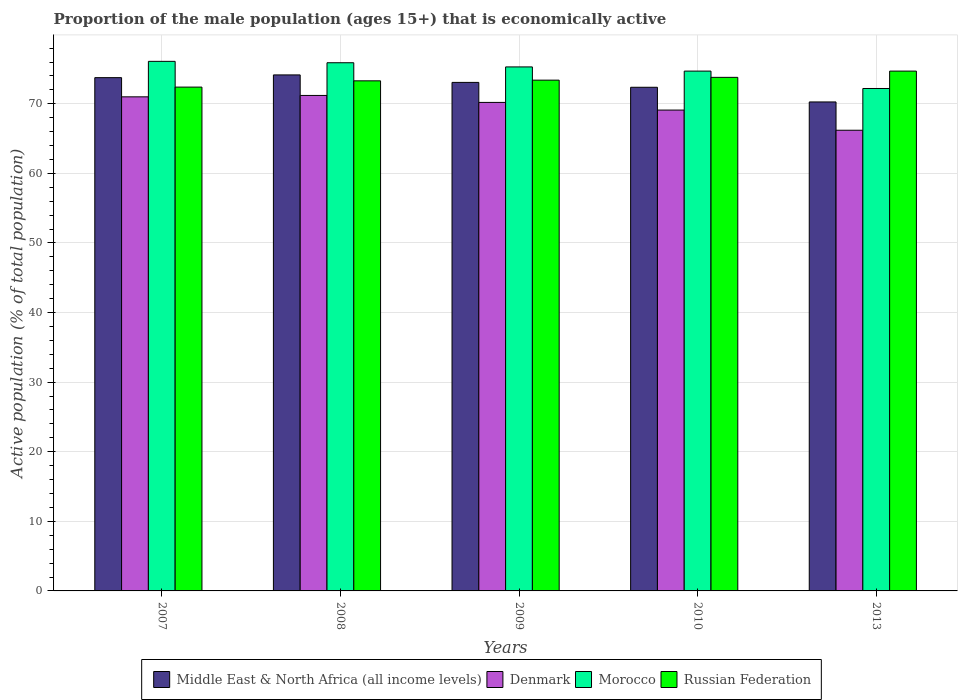How many different coloured bars are there?
Your response must be concise. 4. Are the number of bars per tick equal to the number of legend labels?
Provide a short and direct response. Yes. How many bars are there on the 2nd tick from the right?
Your answer should be very brief. 4. What is the proportion of the male population that is economically active in Denmark in 2010?
Offer a very short reply. 69.1. Across all years, what is the maximum proportion of the male population that is economically active in Morocco?
Your response must be concise. 76.1. Across all years, what is the minimum proportion of the male population that is economically active in Middle East & North Africa (all income levels)?
Your response must be concise. 70.27. What is the total proportion of the male population that is economically active in Russian Federation in the graph?
Your response must be concise. 367.6. What is the difference between the proportion of the male population that is economically active in Denmark in 2007 and that in 2009?
Give a very brief answer. 0.8. What is the difference between the proportion of the male population that is economically active in Denmark in 2009 and the proportion of the male population that is economically active in Morocco in 2013?
Provide a short and direct response. -2. What is the average proportion of the male population that is economically active in Denmark per year?
Give a very brief answer. 69.54. In the year 2007, what is the difference between the proportion of the male population that is economically active in Morocco and proportion of the male population that is economically active in Middle East & North Africa (all income levels)?
Offer a terse response. 2.34. In how many years, is the proportion of the male population that is economically active in Denmark greater than 52 %?
Provide a short and direct response. 5. What is the ratio of the proportion of the male population that is economically active in Morocco in 2008 to that in 2010?
Provide a succinct answer. 1.02. Is the proportion of the male population that is economically active in Morocco in 2007 less than that in 2008?
Keep it short and to the point. No. What is the difference between the highest and the second highest proportion of the male population that is economically active in Middle East & North Africa (all income levels)?
Make the answer very short. 0.39. What is the difference between the highest and the lowest proportion of the male population that is economically active in Russian Federation?
Keep it short and to the point. 2.3. In how many years, is the proportion of the male population that is economically active in Morocco greater than the average proportion of the male population that is economically active in Morocco taken over all years?
Keep it short and to the point. 3. What does the 3rd bar from the left in 2009 represents?
Your answer should be very brief. Morocco. What does the 2nd bar from the right in 2008 represents?
Offer a very short reply. Morocco. How many bars are there?
Your answer should be very brief. 20. Are all the bars in the graph horizontal?
Your response must be concise. No. How many years are there in the graph?
Keep it short and to the point. 5. What is the difference between two consecutive major ticks on the Y-axis?
Your answer should be very brief. 10. Does the graph contain any zero values?
Provide a short and direct response. No. Does the graph contain grids?
Your response must be concise. Yes. Where does the legend appear in the graph?
Ensure brevity in your answer.  Bottom center. How are the legend labels stacked?
Provide a succinct answer. Horizontal. What is the title of the graph?
Give a very brief answer. Proportion of the male population (ages 15+) that is economically active. Does "Heavily indebted poor countries" appear as one of the legend labels in the graph?
Offer a very short reply. No. What is the label or title of the X-axis?
Your answer should be compact. Years. What is the label or title of the Y-axis?
Your answer should be compact. Active population (% of total population). What is the Active population (% of total population) in Middle East & North Africa (all income levels) in 2007?
Your answer should be very brief. 73.76. What is the Active population (% of total population) in Denmark in 2007?
Your answer should be compact. 71. What is the Active population (% of total population) of Morocco in 2007?
Offer a very short reply. 76.1. What is the Active population (% of total population) of Russian Federation in 2007?
Offer a terse response. 72.4. What is the Active population (% of total population) in Middle East & North Africa (all income levels) in 2008?
Keep it short and to the point. 74.15. What is the Active population (% of total population) of Denmark in 2008?
Give a very brief answer. 71.2. What is the Active population (% of total population) of Morocco in 2008?
Offer a terse response. 75.9. What is the Active population (% of total population) of Russian Federation in 2008?
Your answer should be compact. 73.3. What is the Active population (% of total population) in Middle East & North Africa (all income levels) in 2009?
Ensure brevity in your answer.  73.08. What is the Active population (% of total population) in Denmark in 2009?
Provide a short and direct response. 70.2. What is the Active population (% of total population) of Morocco in 2009?
Provide a succinct answer. 75.3. What is the Active population (% of total population) of Russian Federation in 2009?
Give a very brief answer. 73.4. What is the Active population (% of total population) in Middle East & North Africa (all income levels) in 2010?
Provide a short and direct response. 72.38. What is the Active population (% of total population) of Denmark in 2010?
Offer a very short reply. 69.1. What is the Active population (% of total population) in Morocco in 2010?
Provide a succinct answer. 74.7. What is the Active population (% of total population) of Russian Federation in 2010?
Your answer should be very brief. 73.8. What is the Active population (% of total population) of Middle East & North Africa (all income levels) in 2013?
Keep it short and to the point. 70.27. What is the Active population (% of total population) of Denmark in 2013?
Your answer should be very brief. 66.2. What is the Active population (% of total population) of Morocco in 2013?
Ensure brevity in your answer.  72.2. What is the Active population (% of total population) of Russian Federation in 2013?
Your answer should be very brief. 74.7. Across all years, what is the maximum Active population (% of total population) in Middle East & North Africa (all income levels)?
Provide a short and direct response. 74.15. Across all years, what is the maximum Active population (% of total population) of Denmark?
Your answer should be compact. 71.2. Across all years, what is the maximum Active population (% of total population) in Morocco?
Offer a terse response. 76.1. Across all years, what is the maximum Active population (% of total population) of Russian Federation?
Ensure brevity in your answer.  74.7. Across all years, what is the minimum Active population (% of total population) in Middle East & North Africa (all income levels)?
Your answer should be compact. 70.27. Across all years, what is the minimum Active population (% of total population) of Denmark?
Give a very brief answer. 66.2. Across all years, what is the minimum Active population (% of total population) of Morocco?
Provide a short and direct response. 72.2. Across all years, what is the minimum Active population (% of total population) in Russian Federation?
Provide a succinct answer. 72.4. What is the total Active population (% of total population) of Middle East & North Africa (all income levels) in the graph?
Give a very brief answer. 363.63. What is the total Active population (% of total population) of Denmark in the graph?
Make the answer very short. 347.7. What is the total Active population (% of total population) in Morocco in the graph?
Provide a short and direct response. 374.2. What is the total Active population (% of total population) of Russian Federation in the graph?
Offer a terse response. 367.6. What is the difference between the Active population (% of total population) in Middle East & North Africa (all income levels) in 2007 and that in 2008?
Give a very brief answer. -0.39. What is the difference between the Active population (% of total population) in Middle East & North Africa (all income levels) in 2007 and that in 2009?
Keep it short and to the point. 0.68. What is the difference between the Active population (% of total population) in Denmark in 2007 and that in 2009?
Ensure brevity in your answer.  0.8. What is the difference between the Active population (% of total population) of Morocco in 2007 and that in 2009?
Your answer should be very brief. 0.8. What is the difference between the Active population (% of total population) of Russian Federation in 2007 and that in 2009?
Ensure brevity in your answer.  -1. What is the difference between the Active population (% of total population) of Middle East & North Africa (all income levels) in 2007 and that in 2010?
Provide a short and direct response. 1.38. What is the difference between the Active population (% of total population) in Denmark in 2007 and that in 2010?
Keep it short and to the point. 1.9. What is the difference between the Active population (% of total population) in Morocco in 2007 and that in 2010?
Keep it short and to the point. 1.4. What is the difference between the Active population (% of total population) in Russian Federation in 2007 and that in 2010?
Provide a succinct answer. -1.4. What is the difference between the Active population (% of total population) in Middle East & North Africa (all income levels) in 2007 and that in 2013?
Your answer should be very brief. 3.49. What is the difference between the Active population (% of total population) of Denmark in 2007 and that in 2013?
Provide a succinct answer. 4.8. What is the difference between the Active population (% of total population) in Middle East & North Africa (all income levels) in 2008 and that in 2009?
Make the answer very short. 1.08. What is the difference between the Active population (% of total population) in Denmark in 2008 and that in 2009?
Give a very brief answer. 1. What is the difference between the Active population (% of total population) of Middle East & North Africa (all income levels) in 2008 and that in 2010?
Provide a succinct answer. 1.77. What is the difference between the Active population (% of total population) in Denmark in 2008 and that in 2010?
Offer a terse response. 2.1. What is the difference between the Active population (% of total population) in Morocco in 2008 and that in 2010?
Your answer should be very brief. 1.2. What is the difference between the Active population (% of total population) of Russian Federation in 2008 and that in 2010?
Make the answer very short. -0.5. What is the difference between the Active population (% of total population) of Middle East & North Africa (all income levels) in 2008 and that in 2013?
Make the answer very short. 3.88. What is the difference between the Active population (% of total population) of Morocco in 2008 and that in 2013?
Keep it short and to the point. 3.7. What is the difference between the Active population (% of total population) in Middle East & North Africa (all income levels) in 2009 and that in 2010?
Your response must be concise. 0.7. What is the difference between the Active population (% of total population) of Morocco in 2009 and that in 2010?
Offer a terse response. 0.6. What is the difference between the Active population (% of total population) of Middle East & North Africa (all income levels) in 2009 and that in 2013?
Keep it short and to the point. 2.81. What is the difference between the Active population (% of total population) of Morocco in 2009 and that in 2013?
Your answer should be very brief. 3.1. What is the difference between the Active population (% of total population) of Russian Federation in 2009 and that in 2013?
Your response must be concise. -1.3. What is the difference between the Active population (% of total population) in Middle East & North Africa (all income levels) in 2010 and that in 2013?
Offer a terse response. 2.11. What is the difference between the Active population (% of total population) of Denmark in 2010 and that in 2013?
Provide a short and direct response. 2.9. What is the difference between the Active population (% of total population) of Russian Federation in 2010 and that in 2013?
Provide a succinct answer. -0.9. What is the difference between the Active population (% of total population) in Middle East & North Africa (all income levels) in 2007 and the Active population (% of total population) in Denmark in 2008?
Your answer should be compact. 2.56. What is the difference between the Active population (% of total population) of Middle East & North Africa (all income levels) in 2007 and the Active population (% of total population) of Morocco in 2008?
Your response must be concise. -2.14. What is the difference between the Active population (% of total population) of Middle East & North Africa (all income levels) in 2007 and the Active population (% of total population) of Russian Federation in 2008?
Ensure brevity in your answer.  0.46. What is the difference between the Active population (% of total population) of Denmark in 2007 and the Active population (% of total population) of Russian Federation in 2008?
Your answer should be very brief. -2.3. What is the difference between the Active population (% of total population) in Morocco in 2007 and the Active population (% of total population) in Russian Federation in 2008?
Offer a terse response. 2.8. What is the difference between the Active population (% of total population) in Middle East & North Africa (all income levels) in 2007 and the Active population (% of total population) in Denmark in 2009?
Your answer should be very brief. 3.56. What is the difference between the Active population (% of total population) of Middle East & North Africa (all income levels) in 2007 and the Active population (% of total population) of Morocco in 2009?
Ensure brevity in your answer.  -1.54. What is the difference between the Active population (% of total population) in Middle East & North Africa (all income levels) in 2007 and the Active population (% of total population) in Russian Federation in 2009?
Your answer should be compact. 0.36. What is the difference between the Active population (% of total population) of Denmark in 2007 and the Active population (% of total population) of Morocco in 2009?
Offer a terse response. -4.3. What is the difference between the Active population (% of total population) in Morocco in 2007 and the Active population (% of total population) in Russian Federation in 2009?
Give a very brief answer. 2.7. What is the difference between the Active population (% of total population) of Middle East & North Africa (all income levels) in 2007 and the Active population (% of total population) of Denmark in 2010?
Provide a short and direct response. 4.66. What is the difference between the Active population (% of total population) in Middle East & North Africa (all income levels) in 2007 and the Active population (% of total population) in Morocco in 2010?
Provide a succinct answer. -0.94. What is the difference between the Active population (% of total population) of Middle East & North Africa (all income levels) in 2007 and the Active population (% of total population) of Russian Federation in 2010?
Your answer should be compact. -0.04. What is the difference between the Active population (% of total population) in Denmark in 2007 and the Active population (% of total population) in Morocco in 2010?
Keep it short and to the point. -3.7. What is the difference between the Active population (% of total population) of Denmark in 2007 and the Active population (% of total population) of Russian Federation in 2010?
Offer a terse response. -2.8. What is the difference between the Active population (% of total population) of Morocco in 2007 and the Active population (% of total population) of Russian Federation in 2010?
Offer a very short reply. 2.3. What is the difference between the Active population (% of total population) of Middle East & North Africa (all income levels) in 2007 and the Active population (% of total population) of Denmark in 2013?
Make the answer very short. 7.56. What is the difference between the Active population (% of total population) of Middle East & North Africa (all income levels) in 2007 and the Active population (% of total population) of Morocco in 2013?
Provide a short and direct response. 1.56. What is the difference between the Active population (% of total population) in Middle East & North Africa (all income levels) in 2007 and the Active population (% of total population) in Russian Federation in 2013?
Give a very brief answer. -0.94. What is the difference between the Active population (% of total population) in Denmark in 2007 and the Active population (% of total population) in Morocco in 2013?
Give a very brief answer. -1.2. What is the difference between the Active population (% of total population) in Middle East & North Africa (all income levels) in 2008 and the Active population (% of total population) in Denmark in 2009?
Provide a succinct answer. 3.95. What is the difference between the Active population (% of total population) of Middle East & North Africa (all income levels) in 2008 and the Active population (% of total population) of Morocco in 2009?
Provide a short and direct response. -1.15. What is the difference between the Active population (% of total population) in Middle East & North Africa (all income levels) in 2008 and the Active population (% of total population) in Russian Federation in 2009?
Ensure brevity in your answer.  0.75. What is the difference between the Active population (% of total population) of Morocco in 2008 and the Active population (% of total population) of Russian Federation in 2009?
Ensure brevity in your answer.  2.5. What is the difference between the Active population (% of total population) in Middle East & North Africa (all income levels) in 2008 and the Active population (% of total population) in Denmark in 2010?
Ensure brevity in your answer.  5.05. What is the difference between the Active population (% of total population) in Middle East & North Africa (all income levels) in 2008 and the Active population (% of total population) in Morocco in 2010?
Give a very brief answer. -0.55. What is the difference between the Active population (% of total population) in Middle East & North Africa (all income levels) in 2008 and the Active population (% of total population) in Russian Federation in 2010?
Provide a short and direct response. 0.35. What is the difference between the Active population (% of total population) of Denmark in 2008 and the Active population (% of total population) of Russian Federation in 2010?
Offer a terse response. -2.6. What is the difference between the Active population (% of total population) in Morocco in 2008 and the Active population (% of total population) in Russian Federation in 2010?
Provide a succinct answer. 2.1. What is the difference between the Active population (% of total population) in Middle East & North Africa (all income levels) in 2008 and the Active population (% of total population) in Denmark in 2013?
Provide a succinct answer. 7.95. What is the difference between the Active population (% of total population) of Middle East & North Africa (all income levels) in 2008 and the Active population (% of total population) of Morocco in 2013?
Offer a very short reply. 1.95. What is the difference between the Active population (% of total population) in Middle East & North Africa (all income levels) in 2008 and the Active population (% of total population) in Russian Federation in 2013?
Offer a terse response. -0.55. What is the difference between the Active population (% of total population) in Middle East & North Africa (all income levels) in 2009 and the Active population (% of total population) in Denmark in 2010?
Provide a succinct answer. 3.98. What is the difference between the Active population (% of total population) in Middle East & North Africa (all income levels) in 2009 and the Active population (% of total population) in Morocco in 2010?
Keep it short and to the point. -1.62. What is the difference between the Active population (% of total population) in Middle East & North Africa (all income levels) in 2009 and the Active population (% of total population) in Russian Federation in 2010?
Keep it short and to the point. -0.72. What is the difference between the Active population (% of total population) in Denmark in 2009 and the Active population (% of total population) in Morocco in 2010?
Offer a very short reply. -4.5. What is the difference between the Active population (% of total population) of Morocco in 2009 and the Active population (% of total population) of Russian Federation in 2010?
Provide a short and direct response. 1.5. What is the difference between the Active population (% of total population) in Middle East & North Africa (all income levels) in 2009 and the Active population (% of total population) in Denmark in 2013?
Give a very brief answer. 6.88. What is the difference between the Active population (% of total population) of Middle East & North Africa (all income levels) in 2009 and the Active population (% of total population) of Morocco in 2013?
Provide a short and direct response. 0.88. What is the difference between the Active population (% of total population) of Middle East & North Africa (all income levels) in 2009 and the Active population (% of total population) of Russian Federation in 2013?
Your answer should be compact. -1.62. What is the difference between the Active population (% of total population) of Middle East & North Africa (all income levels) in 2010 and the Active population (% of total population) of Denmark in 2013?
Ensure brevity in your answer.  6.18. What is the difference between the Active population (% of total population) in Middle East & North Africa (all income levels) in 2010 and the Active population (% of total population) in Morocco in 2013?
Make the answer very short. 0.18. What is the difference between the Active population (% of total population) in Middle East & North Africa (all income levels) in 2010 and the Active population (% of total population) in Russian Federation in 2013?
Your answer should be very brief. -2.32. What is the difference between the Active population (% of total population) in Denmark in 2010 and the Active population (% of total population) in Morocco in 2013?
Your answer should be compact. -3.1. What is the difference between the Active population (% of total population) of Denmark in 2010 and the Active population (% of total population) of Russian Federation in 2013?
Keep it short and to the point. -5.6. What is the difference between the Active population (% of total population) of Morocco in 2010 and the Active population (% of total population) of Russian Federation in 2013?
Your answer should be very brief. 0. What is the average Active population (% of total population) in Middle East & North Africa (all income levels) per year?
Offer a terse response. 72.73. What is the average Active population (% of total population) in Denmark per year?
Offer a terse response. 69.54. What is the average Active population (% of total population) of Morocco per year?
Your answer should be compact. 74.84. What is the average Active population (% of total population) of Russian Federation per year?
Provide a short and direct response. 73.52. In the year 2007, what is the difference between the Active population (% of total population) of Middle East & North Africa (all income levels) and Active population (% of total population) of Denmark?
Offer a very short reply. 2.76. In the year 2007, what is the difference between the Active population (% of total population) of Middle East & North Africa (all income levels) and Active population (% of total population) of Morocco?
Give a very brief answer. -2.34. In the year 2007, what is the difference between the Active population (% of total population) in Middle East & North Africa (all income levels) and Active population (% of total population) in Russian Federation?
Offer a very short reply. 1.36. In the year 2007, what is the difference between the Active population (% of total population) of Denmark and Active population (% of total population) of Morocco?
Provide a succinct answer. -5.1. In the year 2008, what is the difference between the Active population (% of total population) of Middle East & North Africa (all income levels) and Active population (% of total population) of Denmark?
Provide a succinct answer. 2.95. In the year 2008, what is the difference between the Active population (% of total population) of Middle East & North Africa (all income levels) and Active population (% of total population) of Morocco?
Offer a terse response. -1.75. In the year 2008, what is the difference between the Active population (% of total population) in Middle East & North Africa (all income levels) and Active population (% of total population) in Russian Federation?
Ensure brevity in your answer.  0.85. In the year 2008, what is the difference between the Active population (% of total population) of Denmark and Active population (% of total population) of Morocco?
Offer a very short reply. -4.7. In the year 2008, what is the difference between the Active population (% of total population) of Denmark and Active population (% of total population) of Russian Federation?
Provide a succinct answer. -2.1. In the year 2009, what is the difference between the Active population (% of total population) in Middle East & North Africa (all income levels) and Active population (% of total population) in Denmark?
Give a very brief answer. 2.88. In the year 2009, what is the difference between the Active population (% of total population) of Middle East & North Africa (all income levels) and Active population (% of total population) of Morocco?
Make the answer very short. -2.22. In the year 2009, what is the difference between the Active population (% of total population) of Middle East & North Africa (all income levels) and Active population (% of total population) of Russian Federation?
Offer a very short reply. -0.32. In the year 2010, what is the difference between the Active population (% of total population) in Middle East & North Africa (all income levels) and Active population (% of total population) in Denmark?
Keep it short and to the point. 3.28. In the year 2010, what is the difference between the Active population (% of total population) in Middle East & North Africa (all income levels) and Active population (% of total population) in Morocco?
Offer a very short reply. -2.32. In the year 2010, what is the difference between the Active population (% of total population) in Middle East & North Africa (all income levels) and Active population (% of total population) in Russian Federation?
Your answer should be compact. -1.42. In the year 2010, what is the difference between the Active population (% of total population) of Denmark and Active population (% of total population) of Russian Federation?
Ensure brevity in your answer.  -4.7. In the year 2013, what is the difference between the Active population (% of total population) of Middle East & North Africa (all income levels) and Active population (% of total population) of Denmark?
Make the answer very short. 4.07. In the year 2013, what is the difference between the Active population (% of total population) in Middle East & North Africa (all income levels) and Active population (% of total population) in Morocco?
Offer a terse response. -1.93. In the year 2013, what is the difference between the Active population (% of total population) of Middle East & North Africa (all income levels) and Active population (% of total population) of Russian Federation?
Make the answer very short. -4.43. In the year 2013, what is the difference between the Active population (% of total population) in Denmark and Active population (% of total population) in Russian Federation?
Provide a succinct answer. -8.5. What is the ratio of the Active population (% of total population) of Middle East & North Africa (all income levels) in 2007 to that in 2009?
Offer a very short reply. 1.01. What is the ratio of the Active population (% of total population) in Denmark in 2007 to that in 2009?
Offer a very short reply. 1.01. What is the ratio of the Active population (% of total population) in Morocco in 2007 to that in 2009?
Offer a terse response. 1.01. What is the ratio of the Active population (% of total population) of Russian Federation in 2007 to that in 2009?
Your answer should be very brief. 0.99. What is the ratio of the Active population (% of total population) of Middle East & North Africa (all income levels) in 2007 to that in 2010?
Keep it short and to the point. 1.02. What is the ratio of the Active population (% of total population) of Denmark in 2007 to that in 2010?
Your response must be concise. 1.03. What is the ratio of the Active population (% of total population) of Morocco in 2007 to that in 2010?
Offer a terse response. 1.02. What is the ratio of the Active population (% of total population) of Middle East & North Africa (all income levels) in 2007 to that in 2013?
Your response must be concise. 1.05. What is the ratio of the Active population (% of total population) of Denmark in 2007 to that in 2013?
Ensure brevity in your answer.  1.07. What is the ratio of the Active population (% of total population) of Morocco in 2007 to that in 2013?
Your answer should be very brief. 1.05. What is the ratio of the Active population (% of total population) in Russian Federation in 2007 to that in 2013?
Provide a succinct answer. 0.97. What is the ratio of the Active population (% of total population) of Middle East & North Africa (all income levels) in 2008 to that in 2009?
Your answer should be very brief. 1.01. What is the ratio of the Active population (% of total population) in Denmark in 2008 to that in 2009?
Provide a succinct answer. 1.01. What is the ratio of the Active population (% of total population) in Morocco in 2008 to that in 2009?
Keep it short and to the point. 1.01. What is the ratio of the Active population (% of total population) in Russian Federation in 2008 to that in 2009?
Provide a succinct answer. 1. What is the ratio of the Active population (% of total population) of Middle East & North Africa (all income levels) in 2008 to that in 2010?
Provide a short and direct response. 1.02. What is the ratio of the Active population (% of total population) of Denmark in 2008 to that in 2010?
Provide a short and direct response. 1.03. What is the ratio of the Active population (% of total population) of Morocco in 2008 to that in 2010?
Provide a short and direct response. 1.02. What is the ratio of the Active population (% of total population) of Russian Federation in 2008 to that in 2010?
Ensure brevity in your answer.  0.99. What is the ratio of the Active population (% of total population) of Middle East & North Africa (all income levels) in 2008 to that in 2013?
Give a very brief answer. 1.06. What is the ratio of the Active population (% of total population) in Denmark in 2008 to that in 2013?
Keep it short and to the point. 1.08. What is the ratio of the Active population (% of total population) of Morocco in 2008 to that in 2013?
Your response must be concise. 1.05. What is the ratio of the Active population (% of total population) of Russian Federation in 2008 to that in 2013?
Your answer should be compact. 0.98. What is the ratio of the Active population (% of total population) of Middle East & North Africa (all income levels) in 2009 to that in 2010?
Give a very brief answer. 1.01. What is the ratio of the Active population (% of total population) in Denmark in 2009 to that in 2010?
Your answer should be very brief. 1.02. What is the ratio of the Active population (% of total population) of Morocco in 2009 to that in 2010?
Your answer should be compact. 1.01. What is the ratio of the Active population (% of total population) in Russian Federation in 2009 to that in 2010?
Make the answer very short. 0.99. What is the ratio of the Active population (% of total population) in Denmark in 2009 to that in 2013?
Give a very brief answer. 1.06. What is the ratio of the Active population (% of total population) of Morocco in 2009 to that in 2013?
Ensure brevity in your answer.  1.04. What is the ratio of the Active population (% of total population) of Russian Federation in 2009 to that in 2013?
Provide a short and direct response. 0.98. What is the ratio of the Active population (% of total population) in Middle East & North Africa (all income levels) in 2010 to that in 2013?
Your answer should be compact. 1.03. What is the ratio of the Active population (% of total population) of Denmark in 2010 to that in 2013?
Your answer should be compact. 1.04. What is the ratio of the Active population (% of total population) in Morocco in 2010 to that in 2013?
Your answer should be very brief. 1.03. What is the difference between the highest and the second highest Active population (% of total population) of Middle East & North Africa (all income levels)?
Provide a succinct answer. 0.39. What is the difference between the highest and the second highest Active population (% of total population) of Denmark?
Your answer should be compact. 0.2. What is the difference between the highest and the second highest Active population (% of total population) in Morocco?
Make the answer very short. 0.2. What is the difference between the highest and the lowest Active population (% of total population) of Middle East & North Africa (all income levels)?
Offer a very short reply. 3.88. What is the difference between the highest and the lowest Active population (% of total population) in Denmark?
Your answer should be very brief. 5. What is the difference between the highest and the lowest Active population (% of total population) of Morocco?
Offer a terse response. 3.9. What is the difference between the highest and the lowest Active population (% of total population) in Russian Federation?
Your response must be concise. 2.3. 